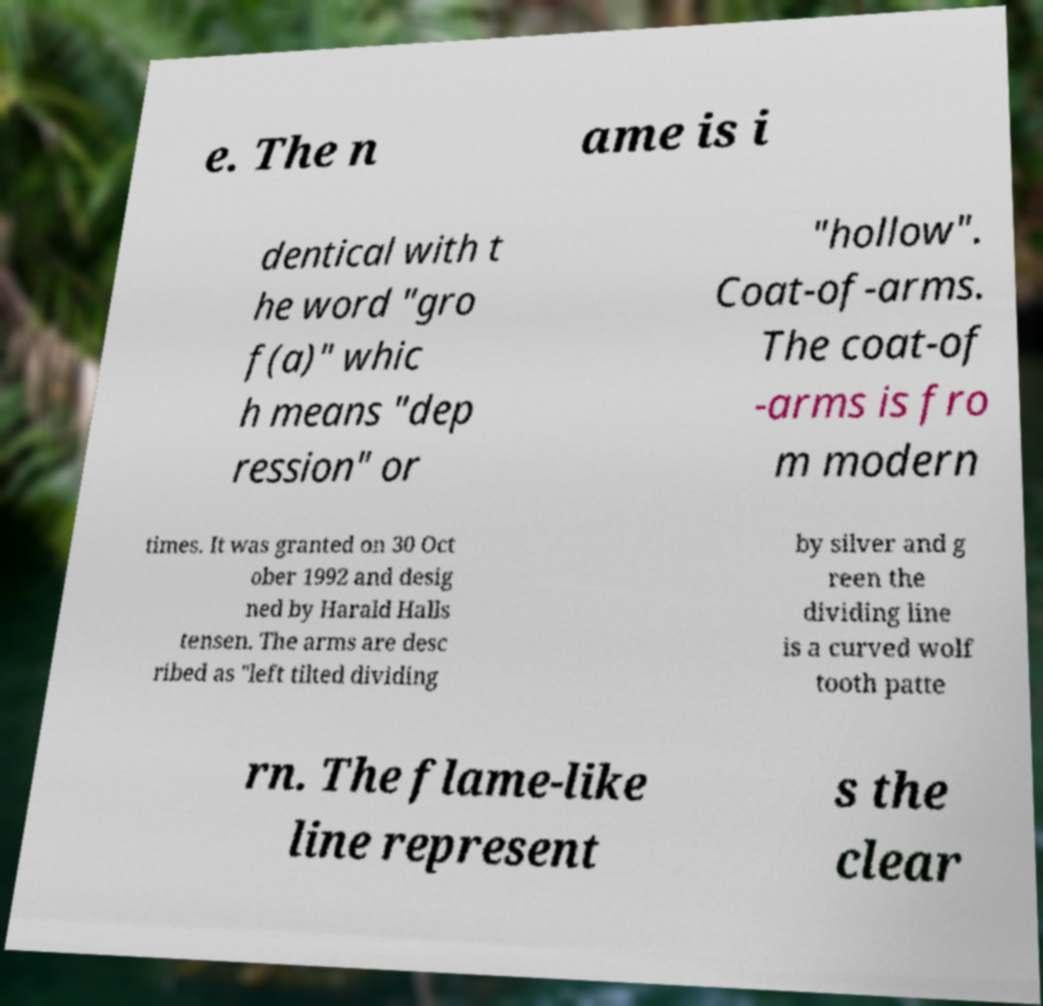Can you accurately transcribe the text from the provided image for me? e. The n ame is i dentical with t he word "gro f(a)" whic h means "dep ression" or "hollow". Coat-of-arms. The coat-of -arms is fro m modern times. It was granted on 30 Oct ober 1992 and desig ned by Harald Halls tensen. The arms are desc ribed as "left tilted dividing by silver and g reen the dividing line is a curved wolf tooth patte rn. The flame-like line represent s the clear 